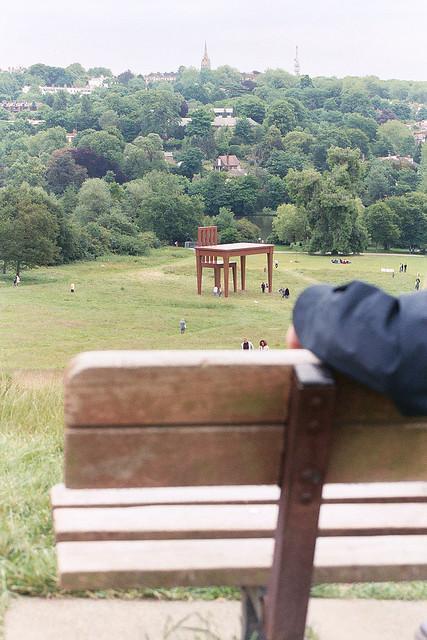How many zebras can be seen?
Give a very brief answer. 0. 